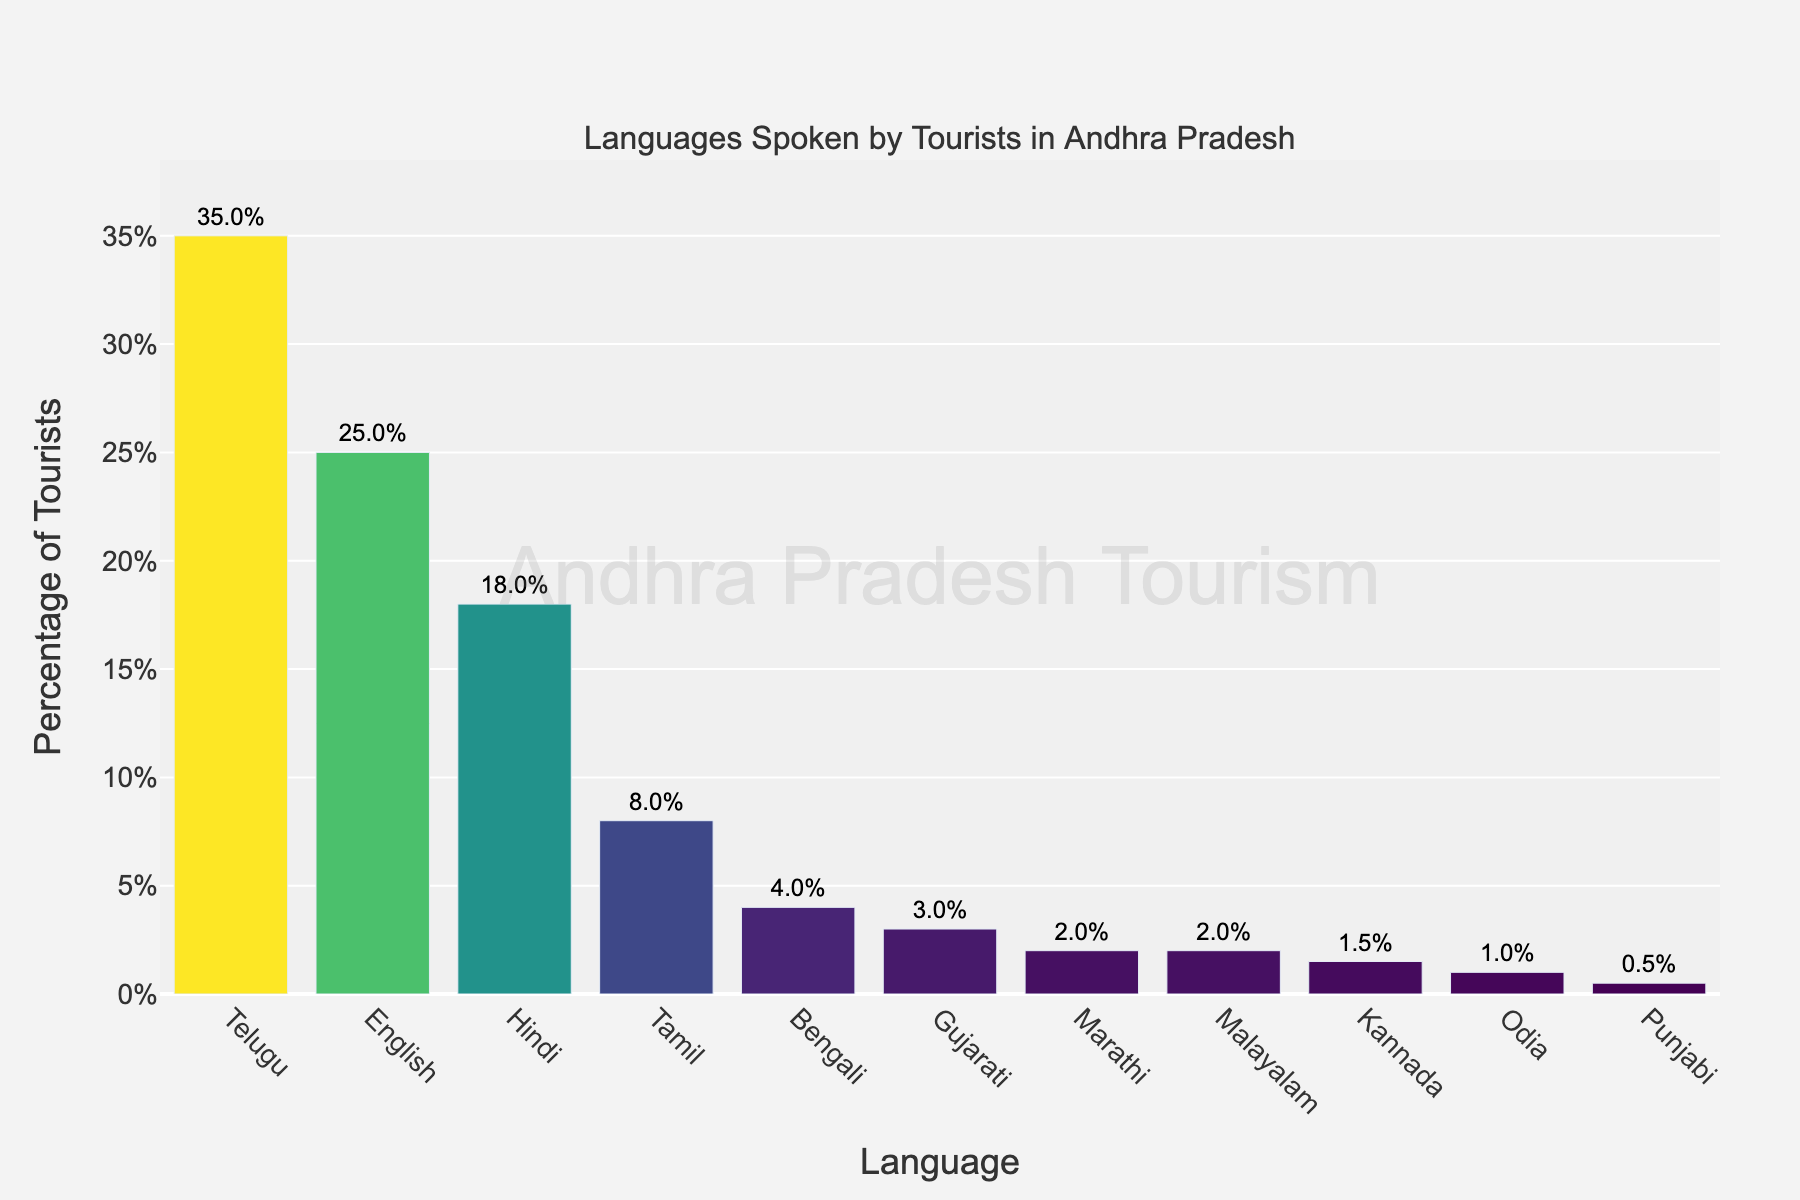Which language is spoken by the highest percentage of tourists? The bar representing Telugu is the tallest, indicating it is spoken by the highest percentage of tourists.
Answer: Telugu Which language is spoken by only 4% of tourists? The bar for Bengali is labeled as 4%, indicating it is spoken by only 4% of tourists.
Answer: Bengali How many languages are spoken by less than 5% of tourists each? Looking at the bars below the 5% mark, we count Bengali, Gujarati, Marathi, Malayalam, Kannada, Odia, and Punjabi for a total of 7 languages.
Answer: 7 What is the total percentage of tourists speaking Hindi, Tamil, and Odia? Add the percentages of Hindi (18%), Tamil (8%), and Odia (1%): 18 + 8 + 1.
Answer: 27% Is the percentage of tourists speaking Tamil greater or less than the percentage of those speaking English? Comparing the bars, Tamil is at 8% and English at 25%, so Tamil is less.
Answer: Less Which language has a percentage twice the percentage of Marathi? Marathi is at 2%, and Bengali is at 4%, which is twice the percentage of Marathi.
Answer: Bengali What is the percentage difference between tourists speaking Telugu and those speaking English? Subtract the percentage of English (25%) from Telugu (35%): 35 - 25.
Answer: 10% What is the combined percentage of tourists speaking Malayalam and Kannada? Add the percentages of Malayalam (2%) and Kannada (1.5%): 2 + 1.5.
Answer: 3.5% Which language spoken by tourists has the least percentage? The smallest bar representing Punjabi is at 0.5%, indicating it has the least percentage.
Answer: Punjabi What is the average percentage of tourists speaking Gujarati and Marathi? Add the percentages of Gujarati (3%) and Marathi (2%), then divide by 2: (3 + 2) / 2.
Answer: 2.5% 